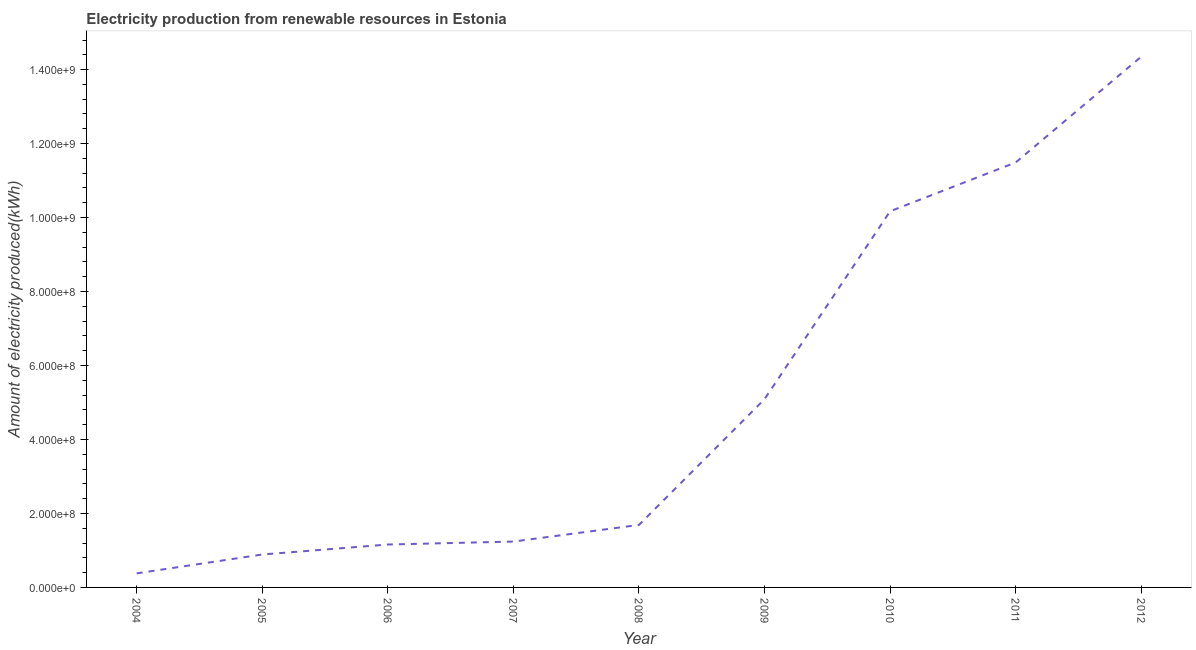What is the amount of electricity produced in 2011?
Keep it short and to the point. 1.15e+09. Across all years, what is the maximum amount of electricity produced?
Your answer should be compact. 1.44e+09. Across all years, what is the minimum amount of electricity produced?
Offer a very short reply. 3.80e+07. What is the sum of the amount of electricity produced?
Your response must be concise. 4.65e+09. What is the difference between the amount of electricity produced in 2008 and 2012?
Provide a succinct answer. -1.27e+09. What is the average amount of electricity produced per year?
Ensure brevity in your answer.  5.16e+08. What is the median amount of electricity produced?
Offer a terse response. 1.69e+08. What is the ratio of the amount of electricity produced in 2004 to that in 2006?
Give a very brief answer. 0.33. What is the difference between the highest and the second highest amount of electricity produced?
Your response must be concise. 2.86e+08. Is the sum of the amount of electricity produced in 2005 and 2011 greater than the maximum amount of electricity produced across all years?
Your answer should be compact. No. What is the difference between the highest and the lowest amount of electricity produced?
Provide a succinct answer. 1.40e+09. How many years are there in the graph?
Provide a succinct answer. 9. What is the difference between two consecutive major ticks on the Y-axis?
Ensure brevity in your answer.  2.00e+08. What is the title of the graph?
Your response must be concise. Electricity production from renewable resources in Estonia. What is the label or title of the Y-axis?
Make the answer very short. Amount of electricity produced(kWh). What is the Amount of electricity produced(kWh) in 2004?
Provide a short and direct response. 3.80e+07. What is the Amount of electricity produced(kWh) in 2005?
Your answer should be very brief. 8.90e+07. What is the Amount of electricity produced(kWh) in 2006?
Your answer should be very brief. 1.16e+08. What is the Amount of electricity produced(kWh) of 2007?
Ensure brevity in your answer.  1.24e+08. What is the Amount of electricity produced(kWh) in 2008?
Provide a short and direct response. 1.69e+08. What is the Amount of electricity produced(kWh) in 2009?
Offer a very short reply. 5.09e+08. What is the Amount of electricity produced(kWh) in 2010?
Keep it short and to the point. 1.02e+09. What is the Amount of electricity produced(kWh) in 2011?
Provide a short and direct response. 1.15e+09. What is the Amount of electricity produced(kWh) in 2012?
Your answer should be very brief. 1.44e+09. What is the difference between the Amount of electricity produced(kWh) in 2004 and 2005?
Ensure brevity in your answer.  -5.10e+07. What is the difference between the Amount of electricity produced(kWh) in 2004 and 2006?
Ensure brevity in your answer.  -7.80e+07. What is the difference between the Amount of electricity produced(kWh) in 2004 and 2007?
Ensure brevity in your answer.  -8.60e+07. What is the difference between the Amount of electricity produced(kWh) in 2004 and 2008?
Offer a very short reply. -1.31e+08. What is the difference between the Amount of electricity produced(kWh) in 2004 and 2009?
Your answer should be compact. -4.71e+08. What is the difference between the Amount of electricity produced(kWh) in 2004 and 2010?
Make the answer very short. -9.79e+08. What is the difference between the Amount of electricity produced(kWh) in 2004 and 2011?
Provide a succinct answer. -1.11e+09. What is the difference between the Amount of electricity produced(kWh) in 2004 and 2012?
Your response must be concise. -1.40e+09. What is the difference between the Amount of electricity produced(kWh) in 2005 and 2006?
Offer a terse response. -2.70e+07. What is the difference between the Amount of electricity produced(kWh) in 2005 and 2007?
Your answer should be compact. -3.50e+07. What is the difference between the Amount of electricity produced(kWh) in 2005 and 2008?
Give a very brief answer. -8.00e+07. What is the difference between the Amount of electricity produced(kWh) in 2005 and 2009?
Keep it short and to the point. -4.20e+08. What is the difference between the Amount of electricity produced(kWh) in 2005 and 2010?
Keep it short and to the point. -9.28e+08. What is the difference between the Amount of electricity produced(kWh) in 2005 and 2011?
Keep it short and to the point. -1.06e+09. What is the difference between the Amount of electricity produced(kWh) in 2005 and 2012?
Make the answer very short. -1.35e+09. What is the difference between the Amount of electricity produced(kWh) in 2006 and 2007?
Your answer should be compact. -8.00e+06. What is the difference between the Amount of electricity produced(kWh) in 2006 and 2008?
Give a very brief answer. -5.30e+07. What is the difference between the Amount of electricity produced(kWh) in 2006 and 2009?
Give a very brief answer. -3.93e+08. What is the difference between the Amount of electricity produced(kWh) in 2006 and 2010?
Offer a very short reply. -9.01e+08. What is the difference between the Amount of electricity produced(kWh) in 2006 and 2011?
Make the answer very short. -1.03e+09. What is the difference between the Amount of electricity produced(kWh) in 2006 and 2012?
Ensure brevity in your answer.  -1.32e+09. What is the difference between the Amount of electricity produced(kWh) in 2007 and 2008?
Your answer should be compact. -4.50e+07. What is the difference between the Amount of electricity produced(kWh) in 2007 and 2009?
Offer a very short reply. -3.85e+08. What is the difference between the Amount of electricity produced(kWh) in 2007 and 2010?
Offer a terse response. -8.93e+08. What is the difference between the Amount of electricity produced(kWh) in 2007 and 2011?
Provide a short and direct response. -1.02e+09. What is the difference between the Amount of electricity produced(kWh) in 2007 and 2012?
Ensure brevity in your answer.  -1.31e+09. What is the difference between the Amount of electricity produced(kWh) in 2008 and 2009?
Offer a very short reply. -3.40e+08. What is the difference between the Amount of electricity produced(kWh) in 2008 and 2010?
Your response must be concise. -8.48e+08. What is the difference between the Amount of electricity produced(kWh) in 2008 and 2011?
Provide a short and direct response. -9.80e+08. What is the difference between the Amount of electricity produced(kWh) in 2008 and 2012?
Offer a terse response. -1.27e+09. What is the difference between the Amount of electricity produced(kWh) in 2009 and 2010?
Ensure brevity in your answer.  -5.08e+08. What is the difference between the Amount of electricity produced(kWh) in 2009 and 2011?
Ensure brevity in your answer.  -6.40e+08. What is the difference between the Amount of electricity produced(kWh) in 2009 and 2012?
Provide a short and direct response. -9.26e+08. What is the difference between the Amount of electricity produced(kWh) in 2010 and 2011?
Provide a short and direct response. -1.32e+08. What is the difference between the Amount of electricity produced(kWh) in 2010 and 2012?
Offer a terse response. -4.18e+08. What is the difference between the Amount of electricity produced(kWh) in 2011 and 2012?
Give a very brief answer. -2.86e+08. What is the ratio of the Amount of electricity produced(kWh) in 2004 to that in 2005?
Keep it short and to the point. 0.43. What is the ratio of the Amount of electricity produced(kWh) in 2004 to that in 2006?
Your answer should be compact. 0.33. What is the ratio of the Amount of electricity produced(kWh) in 2004 to that in 2007?
Provide a short and direct response. 0.31. What is the ratio of the Amount of electricity produced(kWh) in 2004 to that in 2008?
Give a very brief answer. 0.23. What is the ratio of the Amount of electricity produced(kWh) in 2004 to that in 2009?
Provide a succinct answer. 0.07. What is the ratio of the Amount of electricity produced(kWh) in 2004 to that in 2010?
Keep it short and to the point. 0.04. What is the ratio of the Amount of electricity produced(kWh) in 2004 to that in 2011?
Keep it short and to the point. 0.03. What is the ratio of the Amount of electricity produced(kWh) in 2004 to that in 2012?
Give a very brief answer. 0.03. What is the ratio of the Amount of electricity produced(kWh) in 2005 to that in 2006?
Provide a succinct answer. 0.77. What is the ratio of the Amount of electricity produced(kWh) in 2005 to that in 2007?
Make the answer very short. 0.72. What is the ratio of the Amount of electricity produced(kWh) in 2005 to that in 2008?
Make the answer very short. 0.53. What is the ratio of the Amount of electricity produced(kWh) in 2005 to that in 2009?
Keep it short and to the point. 0.17. What is the ratio of the Amount of electricity produced(kWh) in 2005 to that in 2010?
Provide a succinct answer. 0.09. What is the ratio of the Amount of electricity produced(kWh) in 2005 to that in 2011?
Provide a short and direct response. 0.08. What is the ratio of the Amount of electricity produced(kWh) in 2005 to that in 2012?
Your answer should be compact. 0.06. What is the ratio of the Amount of electricity produced(kWh) in 2006 to that in 2007?
Give a very brief answer. 0.94. What is the ratio of the Amount of electricity produced(kWh) in 2006 to that in 2008?
Offer a very short reply. 0.69. What is the ratio of the Amount of electricity produced(kWh) in 2006 to that in 2009?
Offer a terse response. 0.23. What is the ratio of the Amount of electricity produced(kWh) in 2006 to that in 2010?
Ensure brevity in your answer.  0.11. What is the ratio of the Amount of electricity produced(kWh) in 2006 to that in 2011?
Your response must be concise. 0.1. What is the ratio of the Amount of electricity produced(kWh) in 2006 to that in 2012?
Your answer should be compact. 0.08. What is the ratio of the Amount of electricity produced(kWh) in 2007 to that in 2008?
Provide a short and direct response. 0.73. What is the ratio of the Amount of electricity produced(kWh) in 2007 to that in 2009?
Give a very brief answer. 0.24. What is the ratio of the Amount of electricity produced(kWh) in 2007 to that in 2010?
Provide a short and direct response. 0.12. What is the ratio of the Amount of electricity produced(kWh) in 2007 to that in 2011?
Offer a very short reply. 0.11. What is the ratio of the Amount of electricity produced(kWh) in 2007 to that in 2012?
Provide a succinct answer. 0.09. What is the ratio of the Amount of electricity produced(kWh) in 2008 to that in 2009?
Ensure brevity in your answer.  0.33. What is the ratio of the Amount of electricity produced(kWh) in 2008 to that in 2010?
Offer a very short reply. 0.17. What is the ratio of the Amount of electricity produced(kWh) in 2008 to that in 2011?
Offer a very short reply. 0.15. What is the ratio of the Amount of electricity produced(kWh) in 2008 to that in 2012?
Your answer should be very brief. 0.12. What is the ratio of the Amount of electricity produced(kWh) in 2009 to that in 2010?
Provide a succinct answer. 0.5. What is the ratio of the Amount of electricity produced(kWh) in 2009 to that in 2011?
Give a very brief answer. 0.44. What is the ratio of the Amount of electricity produced(kWh) in 2009 to that in 2012?
Your answer should be compact. 0.35. What is the ratio of the Amount of electricity produced(kWh) in 2010 to that in 2011?
Your answer should be very brief. 0.89. What is the ratio of the Amount of electricity produced(kWh) in 2010 to that in 2012?
Provide a succinct answer. 0.71. What is the ratio of the Amount of electricity produced(kWh) in 2011 to that in 2012?
Provide a succinct answer. 0.8. 